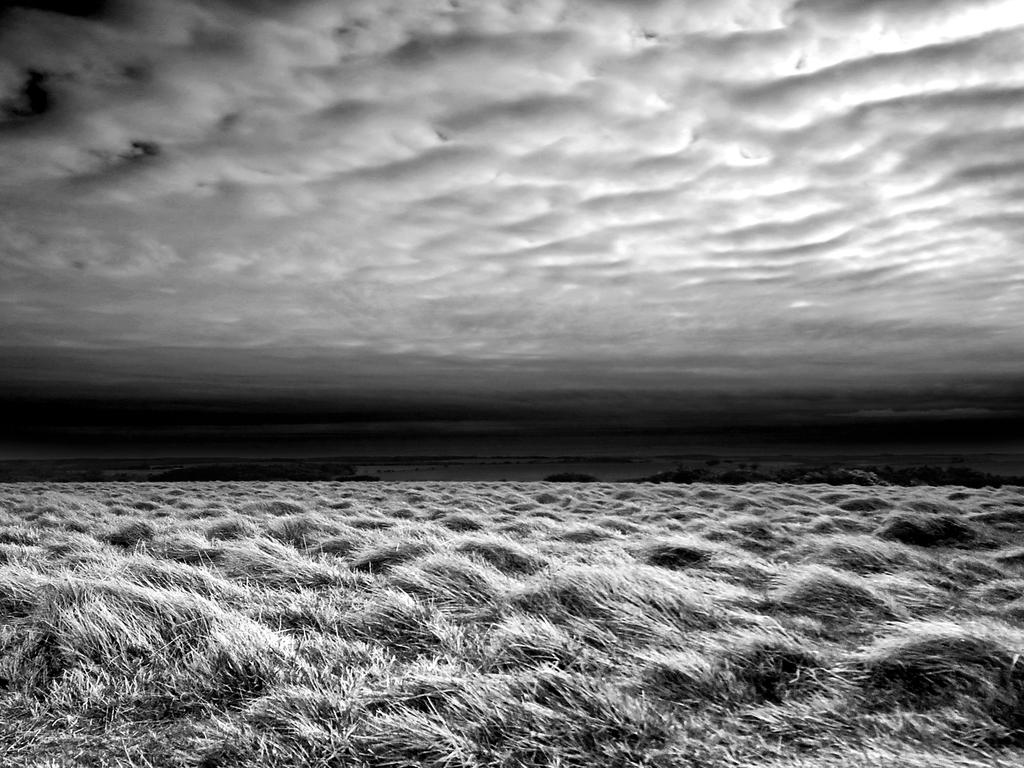What type of vegetation can be seen in the image? There is grass in the image. What else is present in the image besides the grass? There are objects in the image. What can be seen in the background of the image? The sky is visible in the background of the image. What is the condition of the sky in the image? Clouds are present in the sky. What type of milk is being used to improve the acoustics in the image? There is no milk or mention of acoustics in the image; it features grass, objects, and a sky with clouds. 